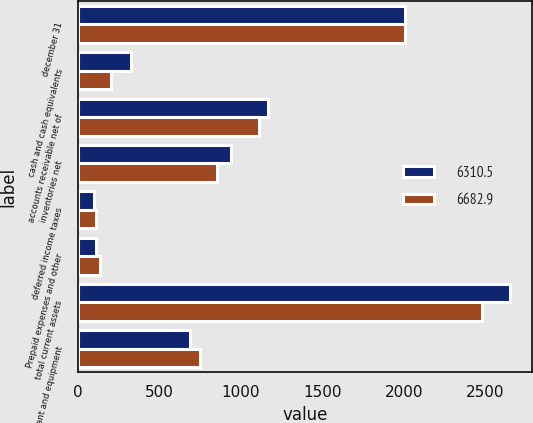Convert chart. <chart><loc_0><loc_0><loc_500><loc_500><stacked_bar_chart><ecel><fcel>december 31<fcel>cash and cash equivalents<fcel>accounts receivable net of<fcel>inventories net<fcel>deferred income taxes<fcel>Prepaid expenses and other<fcel>total current assets<fcel>Property plant and equipment<nl><fcel>6310.5<fcel>2007<fcel>329.2<fcel>1166.4<fcel>940.4<fcel>102<fcel>113.7<fcel>2651.7<fcel>688.6<nl><fcel>6682.9<fcel>2006<fcel>201<fcel>1113.6<fcel>850.6<fcel>110.1<fcel>133.5<fcel>2476.9<fcel>746.9<nl></chart> 